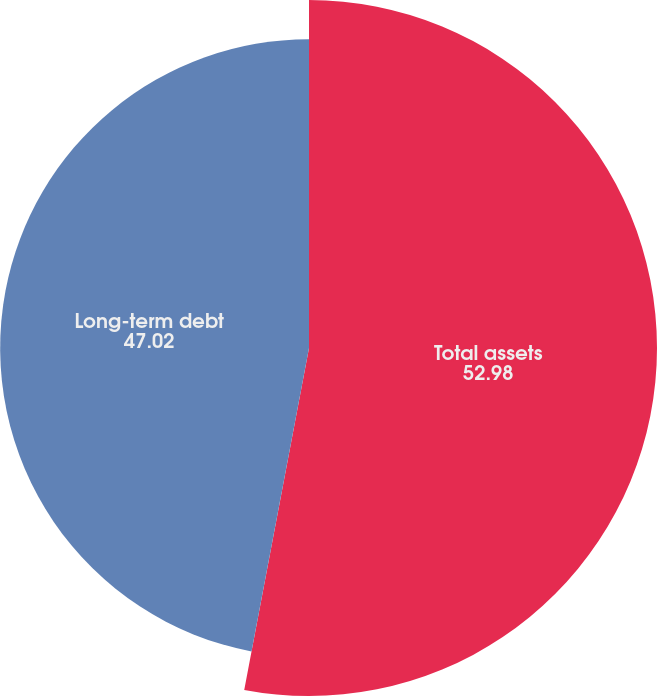<chart> <loc_0><loc_0><loc_500><loc_500><pie_chart><fcel>Total assets<fcel>Long-term debt<nl><fcel>52.98%<fcel>47.02%<nl></chart> 